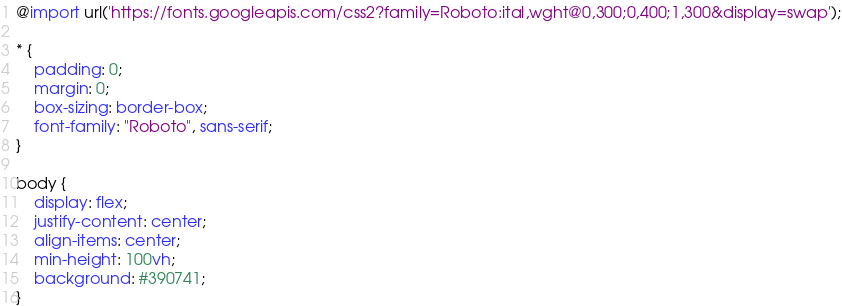Convert code to text. <code><loc_0><loc_0><loc_500><loc_500><_CSS_>@import url('https://fonts.googleapis.com/css2?family=Roboto:ital,wght@0,300;0,400;1,300&display=swap');

* {
    padding: 0;
    margin: 0;
    box-sizing: border-box;
    font-family: "Roboto", sans-serif;
}

body {
    display: flex;
    justify-content: center;
    align-items: center;
    min-height: 100vh;
    background: #390741;
}
</code> 